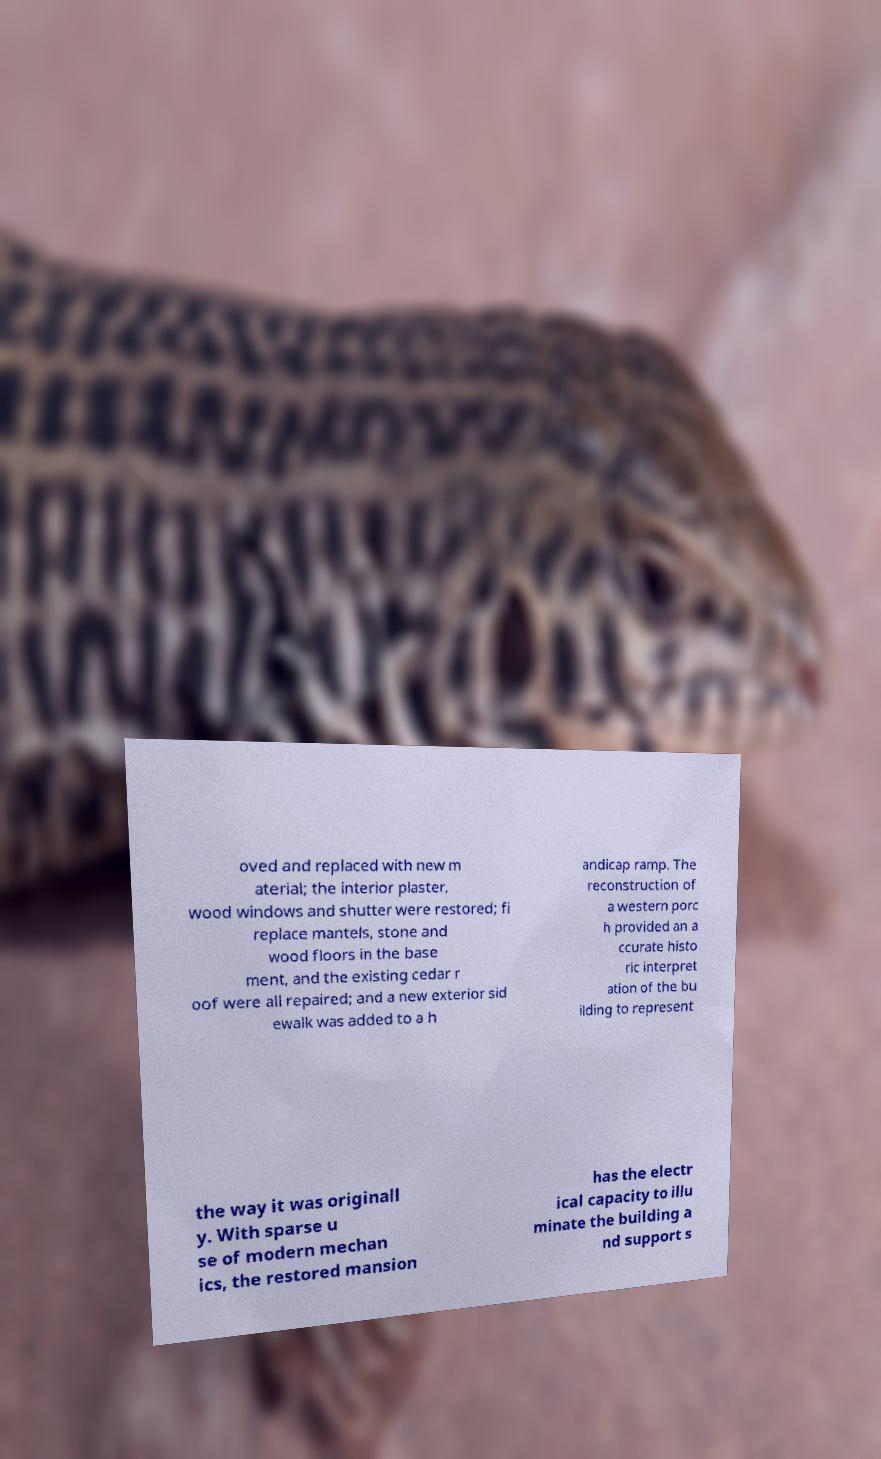Please read and relay the text visible in this image. What does it say? oved and replaced with new m aterial; the interior plaster, wood windows and shutter were restored; fi replace mantels, stone and wood floors in the base ment, and the existing cedar r oof were all repaired; and a new exterior sid ewalk was added to a h andicap ramp. The reconstruction of a western porc h provided an a ccurate histo ric interpret ation of the bu ilding to represent the way it was originall y. With sparse u se of modern mechan ics, the restored mansion has the electr ical capacity to illu minate the building a nd support s 